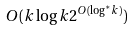<formula> <loc_0><loc_0><loc_500><loc_500>O ( k \log k 2 ^ { O ( \log ^ { * } k ) } )</formula> 